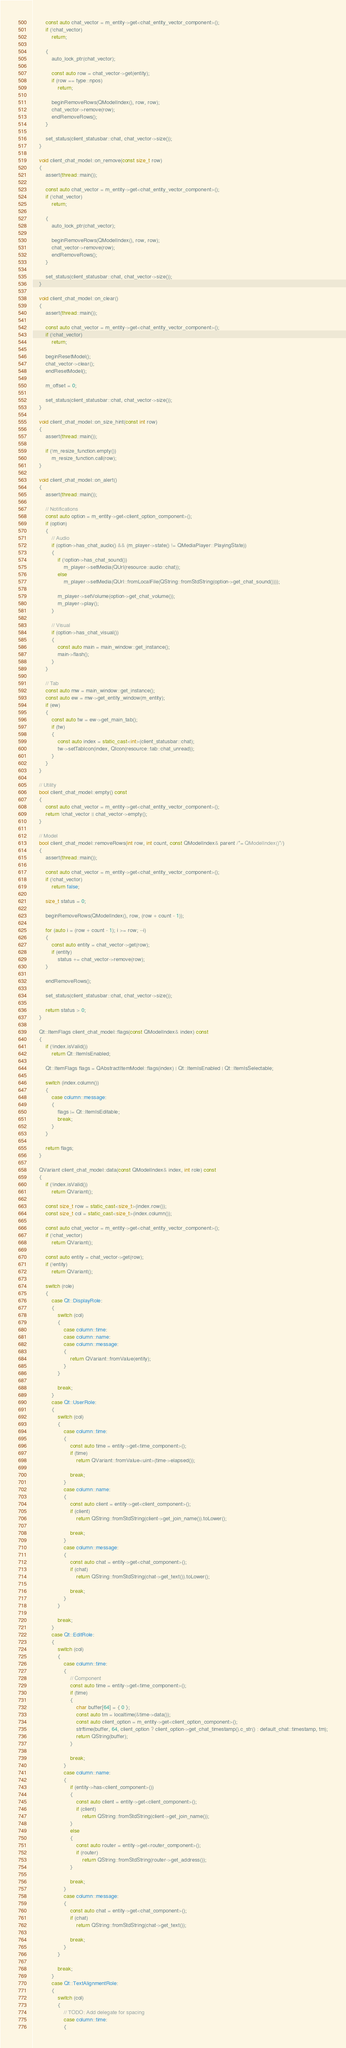Convert code to text. <code><loc_0><loc_0><loc_500><loc_500><_C++_>
		const auto chat_vector = m_entity->get<chat_entity_vector_component>();
		if (!chat_vector)
			return;

		{
			auto_lock_ptr(chat_vector);

			const auto row = chat_vector->get(entity);
			if (row == type::npos)
				return;

			beginRemoveRows(QModelIndex(), row, row);
			chat_vector->remove(row);
			endRemoveRows();
		}

		set_status(client_statusbar::chat, chat_vector->size());
	}

	void client_chat_model::on_remove(const size_t row)
	{
		assert(thread::main());

		const auto chat_vector = m_entity->get<chat_entity_vector_component>();
		if (!chat_vector)
			return;

		{
			auto_lock_ptr(chat_vector);

			beginRemoveRows(QModelIndex(), row, row);
			chat_vector->remove(row);
			endRemoveRows();
		}

		set_status(client_statusbar::chat, chat_vector->size());
	}

	void client_chat_model::on_clear()
	{
		assert(thread::main());

		const auto chat_vector = m_entity->get<chat_entity_vector_component>();
		if (!chat_vector)
			return;

		beginResetModel();
		chat_vector->clear();
		endResetModel();

		m_offset = 0;

		set_status(client_statusbar::chat, chat_vector->size());
	}

	void client_chat_model::on_size_hint(const int row)
	{
		assert(thread::main());

		if (!m_resize_function.empty())
			m_resize_function.call(row);
	}

	void client_chat_model::on_alert()
	{
		assert(thread::main());

		// Notifications			
		const auto option = m_entity->get<client_option_component>();
		if (option)
		{
			// Audio
			if (option->has_chat_audio() && (m_player->state() != QMediaPlayer::PlayingState))
			{
				if (!option->has_chat_sound())
					m_player->setMedia(QUrl(resource::audio::chat));
				else
					m_player->setMedia(QUrl::fromLocalFile(QString::fromStdString(option->get_chat_sound())));

				m_player->setVolume(option->get_chat_volume());
				m_player->play();
			}

			// Visual
			if (option->has_chat_visual())
			{
				const auto main = main_window::get_instance();
				main->flash();
			}
		}

		// Tab
		const auto mw = main_window::get_instance();
		const auto ew = mw->get_entity_window(m_entity);
		if (ew)
		{
			const auto tw = ew->get_main_tab();
			if (tw)
			{
				const auto index = static_cast<int>(client_statusbar::chat);
				tw->setTabIcon(index, QIcon(resource::tab::chat_unread));
			}
		}
	}

	// Utility
	bool client_chat_model::empty() const
	{
		const auto chat_vector = m_entity->get<chat_entity_vector_component>();
		return !chat_vector || chat_vector->empty();
	}

	// Model
	bool client_chat_model::removeRows(int row, int count, const QModelIndex& parent /*= QModelIndex()*/)
	{
		assert(thread::main());

		const auto chat_vector = m_entity->get<chat_entity_vector_component>();
		if (!chat_vector)
			return false;

		size_t status = 0;

		beginRemoveRows(QModelIndex(), row, (row + count - 1));

		for (auto i = (row + count - 1); i >= row; --i)
		{
			const auto entity = chat_vector->get(row);
			if (entity)
				status += chat_vector->remove(row);
		}

		endRemoveRows();

		set_status(client_statusbar::chat, chat_vector->size());

		return status > 0;
	}

	Qt::ItemFlags client_chat_model::flags(const QModelIndex& index) const
	{
		if (!index.isValid())
			return Qt::ItemIsEnabled;

		Qt::ItemFlags flags = QAbstractItemModel::flags(index) | Qt::ItemIsEnabled | Qt::ItemIsSelectable;

		switch (index.column())
		{
			case column::message:
			{
				flags |= Qt::ItemIsEditable;
				break;
			}
		}

		return flags;
	}

	QVariant client_chat_model::data(const QModelIndex& index, int role) const
	{
		if (!index.isValid())
			return QVariant();

		const size_t row = static_cast<size_t>(index.row());
		const size_t col = static_cast<size_t>(index.column());

		const auto chat_vector = m_entity->get<chat_entity_vector_component>();
		if (!chat_vector)
			return QVariant();

		const auto entity = chat_vector->get(row);
		if (!entity)
			return QVariant();

		switch (role)
		{
			case Qt::DisplayRole:
			{
				switch (col)
				{
					case column::time:
					case column::name:
					case column::message:
					{
						return QVariant::fromValue(entity);
					}
				}

				break;
			}
			case Qt::UserRole:
			{
				switch (col)
				{
					case column::time:
					{
						const auto time = entity->get<time_component>();
						if (time)
							return QVariant::fromValue<uint>(time->elapsed());

						break;
					}
					case column::name:
					{
						const auto client = entity->get<client_component>();
						if (client)
							return QString::fromStdString(client->get_join_name()).toLower();

						break;
					}					
					case column::message:
					{
						const auto chat = entity->get<chat_component>();
						if (chat)
							return QString::fromStdString(chat->get_text()).toLower();

						break;
					}
				}

				break;
			}
			case Qt::EditRole:
			{
				switch (col)
				{
					case column::time:
					{
						// Component
						const auto time = entity->get<time_component>();
						if (time)
						{
							char buffer[64] = { 0 };
							const auto tm = localtime(&time->data());
							const auto client_option = m_entity->get<client_option_component>();
							strftime(buffer, 64, client_option ? client_option->get_chat_timestamp().c_str() : default_chat::timestamp, tm);
							return QString(buffer);
						}

						break;
					}
					case column::name:
					{
						if (entity->has<client_component>())
						{
							const auto client = entity->get<client_component>();
							if (client)
								return QString::fromStdString(client->get_join_name());
						}
						else
						{
							const auto router = entity->get<router_component>();
							if (router)
								return QString::fromStdString(router->get_address());
						}

						break;
					}					
					case column::message:
					{
						const auto chat = entity->get<chat_component>();
						if (chat)
							return QString::fromStdString(chat->get_text());

						break;
					}
				}

				break;
			}
			case Qt::TextAlignmentRole:
			{
				switch (col)
				{
					// TODO: Add delegate for spacing
					case column::time:
					{</code> 